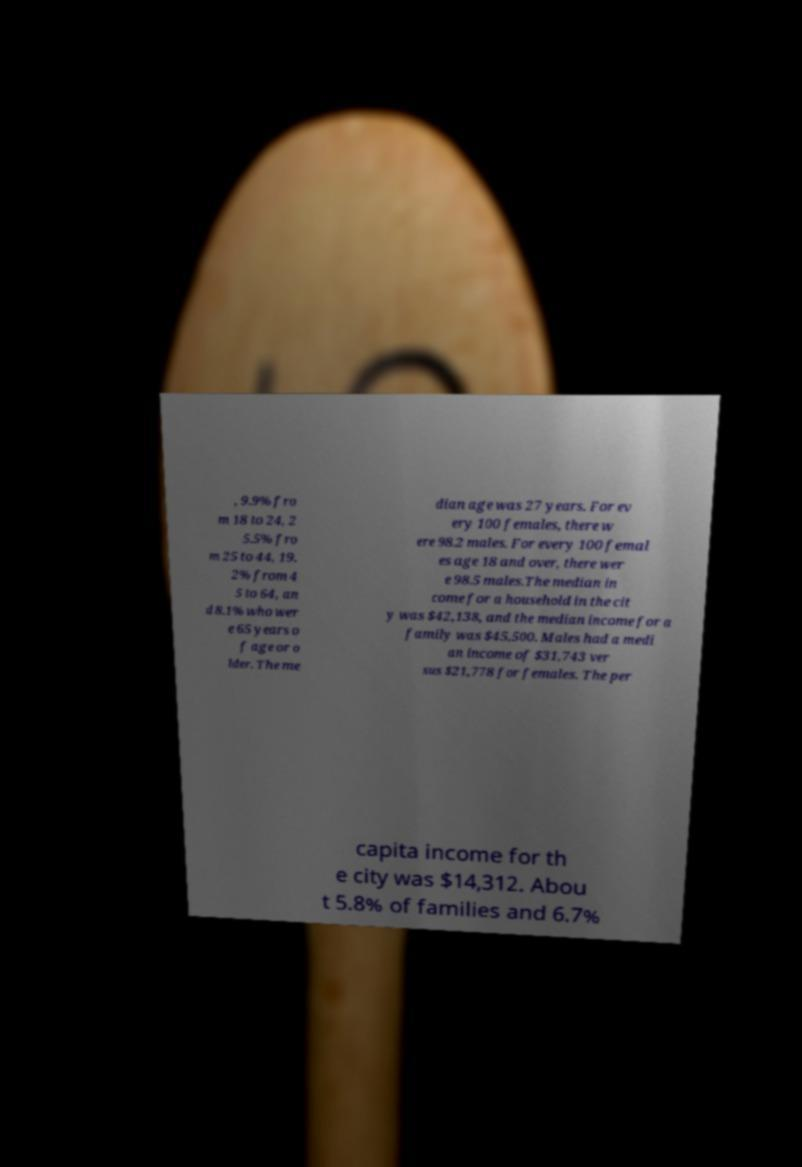Can you accurately transcribe the text from the provided image for me? , 9.9% fro m 18 to 24, 2 5.5% fro m 25 to 44, 19. 2% from 4 5 to 64, an d 8.1% who wer e 65 years o f age or o lder. The me dian age was 27 years. For ev ery 100 females, there w ere 98.2 males. For every 100 femal es age 18 and over, there wer e 98.5 males.The median in come for a household in the cit y was $42,138, and the median income for a family was $45,500. Males had a medi an income of $31,743 ver sus $21,778 for females. The per capita income for th e city was $14,312. Abou t 5.8% of families and 6.7% 